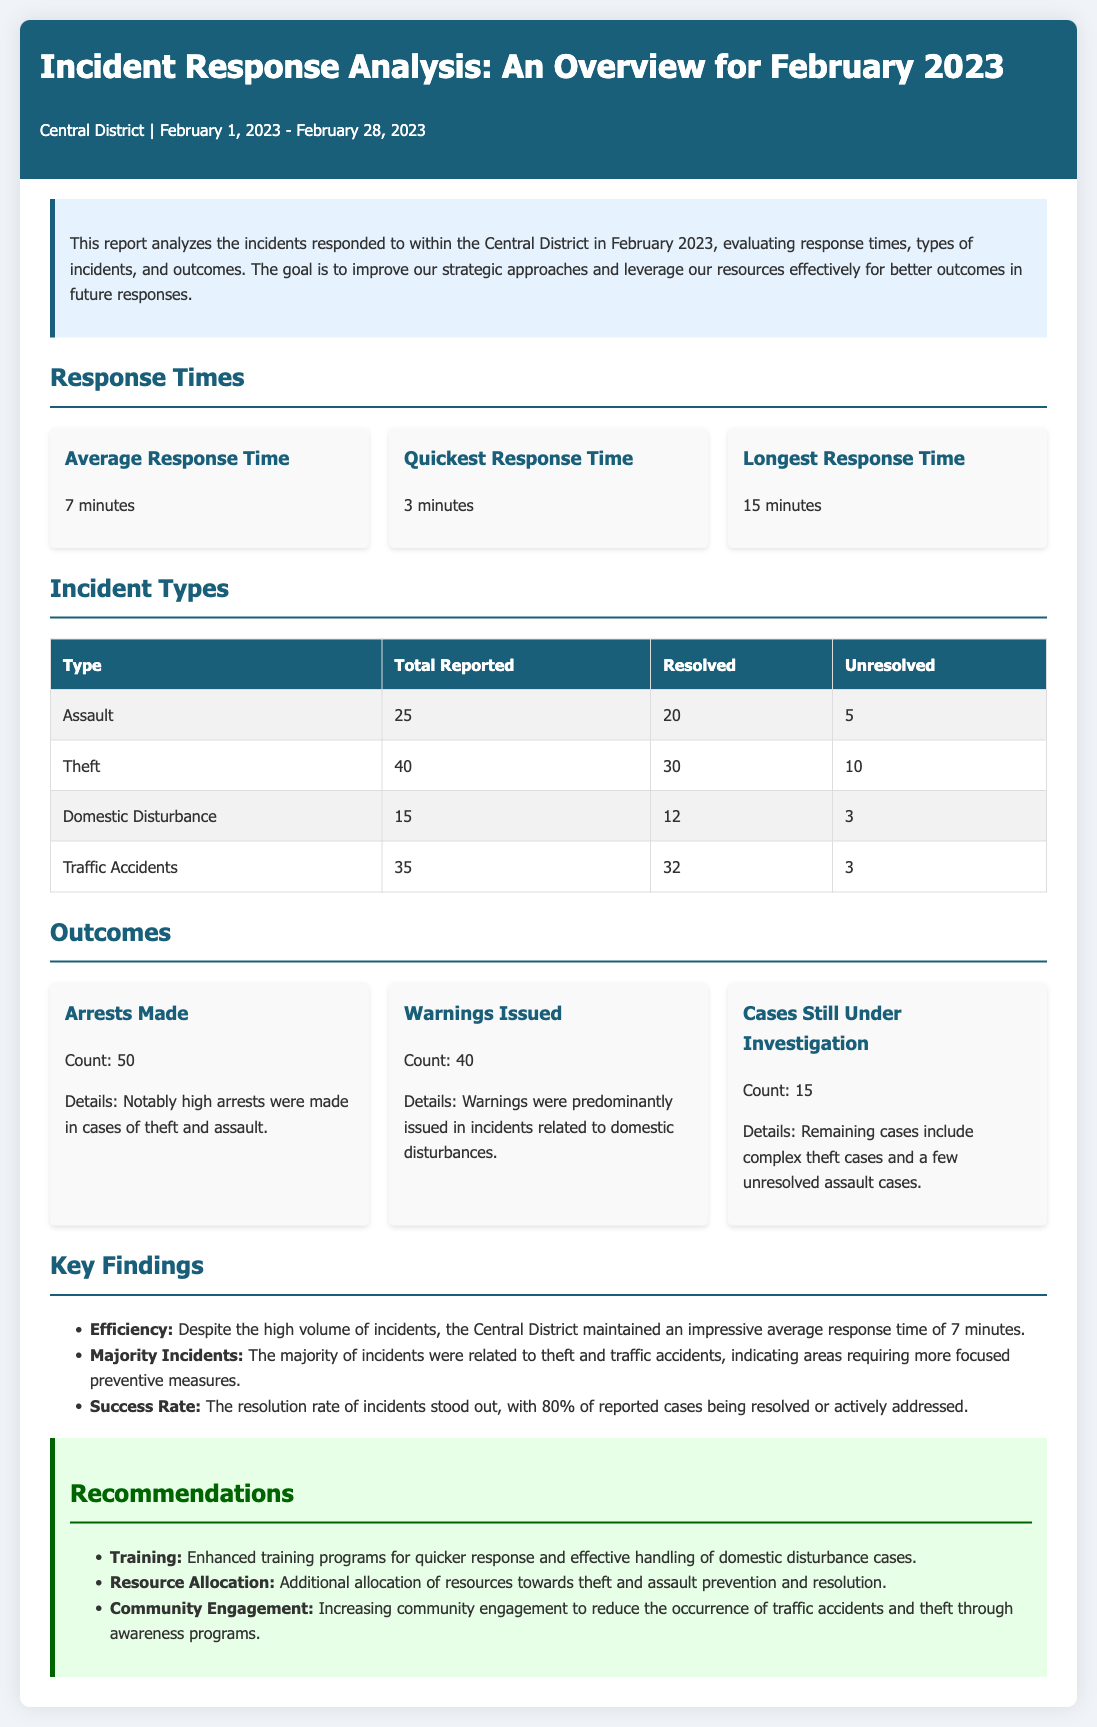What is the average response time? The average response time is reported as 7 minutes in the document.
Answer: 7 minutes What type of incident had the most total reported cases? The incident type with the most reported cases is theft, with 40 reported incidents.
Answer: Theft How many arrests were made in February 2023? The document states that 50 arrests were made during the response to incidents.
Answer: 50 What is the quickest response time recorded? According to the report, the quickest response time is 3 minutes.
Answer: 3 minutes What percentage of reported cases were resolved or actively addressed? The resolution rate indicates that 80% of reported cases were resolved.
Answer: 80% What type of incidents received warnings predominantly? Warnings were predominantly issued in incidents related to domestic disturbances.
Answer: Domestic Disturbance How many cases are still under investigation? The document mentions that 15 cases are still under investigation.
Answer: 15 What is one recommendation mentioned for improving incident response? One recommendation is to enhance training programs for quicker response handling.
Answer: Enhanced training programs 